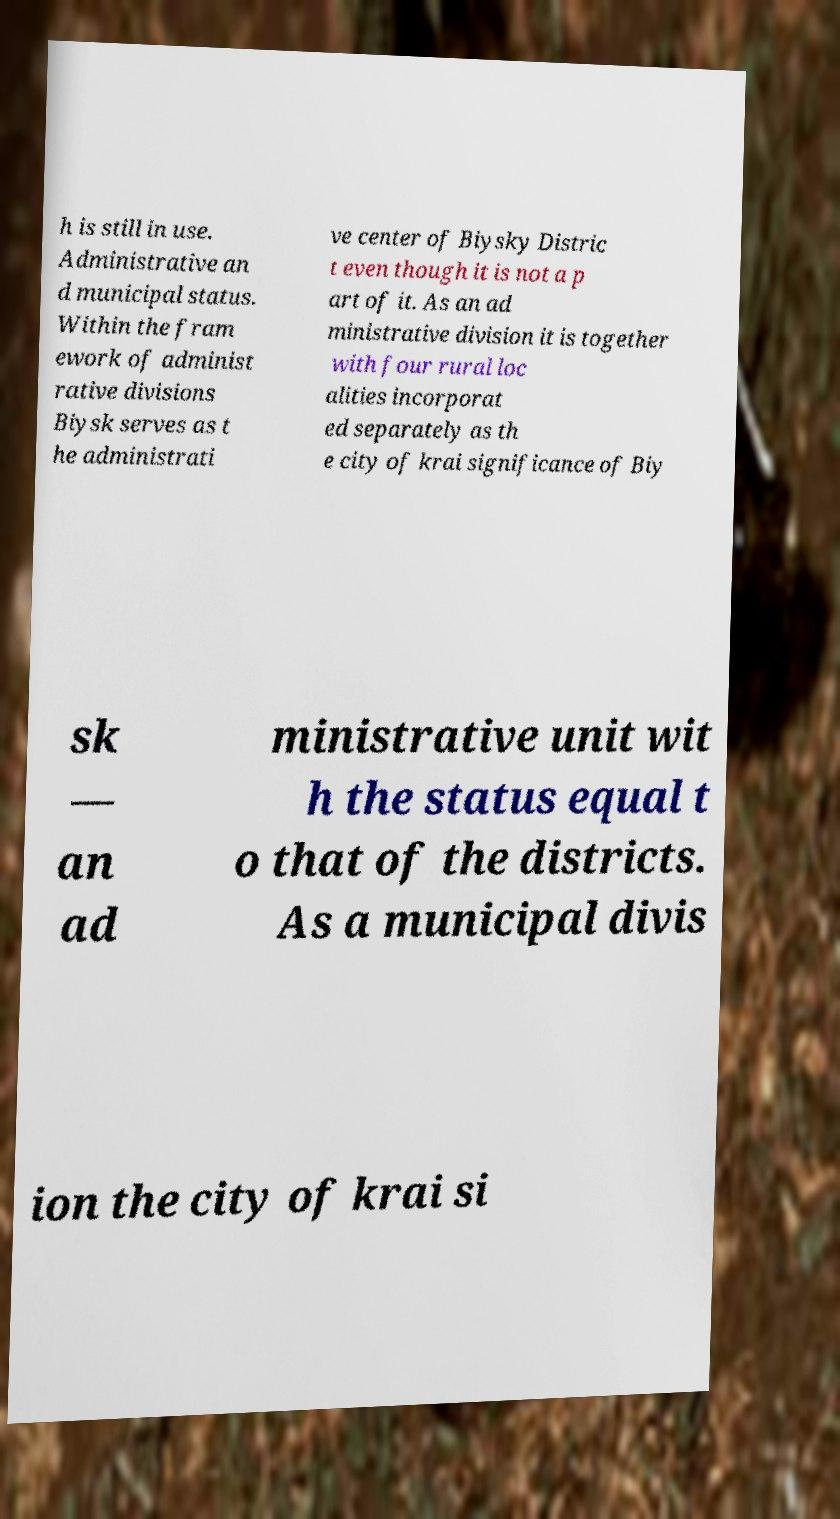Please identify and transcribe the text found in this image. h is still in use. Administrative an d municipal status. Within the fram ework of administ rative divisions Biysk serves as t he administrati ve center of Biysky Distric t even though it is not a p art of it. As an ad ministrative division it is together with four rural loc alities incorporat ed separately as th e city of krai significance of Biy sk — an ad ministrative unit wit h the status equal t o that of the districts. As a municipal divis ion the city of krai si 